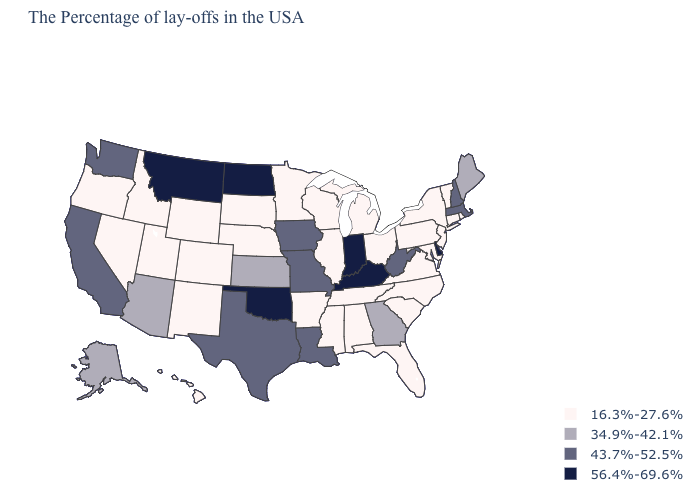Does Maryland have the same value as Oklahoma?
Give a very brief answer. No. Name the states that have a value in the range 34.9%-42.1%?
Keep it brief. Maine, Georgia, Kansas, Arizona, Alaska. What is the value of Missouri?
Give a very brief answer. 43.7%-52.5%. Which states have the highest value in the USA?
Answer briefly. Delaware, Kentucky, Indiana, Oklahoma, North Dakota, Montana. What is the lowest value in the USA?
Short answer required. 16.3%-27.6%. Which states have the highest value in the USA?
Give a very brief answer. Delaware, Kentucky, Indiana, Oklahoma, North Dakota, Montana. Among the states that border New Mexico , which have the lowest value?
Keep it brief. Colorado, Utah. What is the value of New Mexico?
Quick response, please. 16.3%-27.6%. What is the value of Alabama?
Concise answer only. 16.3%-27.6%. Does the map have missing data?
Short answer required. No. Does the map have missing data?
Short answer required. No. What is the value of Wyoming?
Quick response, please. 16.3%-27.6%. What is the highest value in the MidWest ?
Answer briefly. 56.4%-69.6%. What is the highest value in the USA?
Short answer required. 56.4%-69.6%. What is the value of Oklahoma?
Concise answer only. 56.4%-69.6%. 